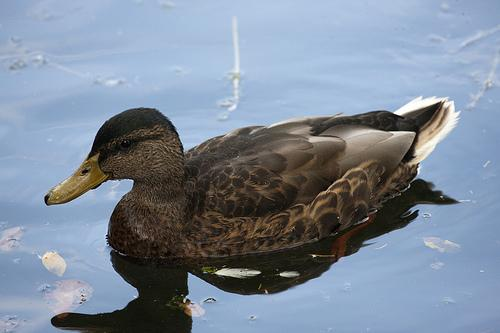Determine the total number of objects detected in the image. There are 39 objects detected in the image. Count and describe the distinctive ripples in the blue water around the duck. There are 9 ripples in the blue water, with varying sizes and shapes. What color is the eye of the duck in the image? The eye of the duck is small and black. What is floating around the duck in the water? There are orange leaves, a branch, and ripples floating around the duck in the water. What is the overall color and mood of the water surrounding the duck? The water is dark blue and calm, with areas of clear light blue, creating a serene mood. Describe the sentiment evoked by the image. The image evokes a sense of calmness and serenity, as the duck peacefully swims in the tranquil water. Give a brief caption summarizing the image. A brown duck swimming in calm and clear blue water with floating leaves and ripples. In your own words, describe the appearance of the duck in the image. The brown duck has a white feathered tail, black and gray feathered body, with bron feathers containing black dots. What is the unique feature on the duck's head and peak? The unique feature is a black line on the duck's head and a little black dot on its peak. Identify any two object interactions taking place in the image. The duck's beak is touching the water, and the tail feathers are interacting with the surrounding water, creating ripples. What is the color of the duck's beak? Brown Which part of the duck appears to have black and gray feathers?  Body What kind of feathered body part is observed in the tail of the duck?  White feathered tail What type of leaves are floating in the water?  Orange leaves What type of body part is pst pf ducks wing feathers?  Part of the brown duck's wing feathers Give a summary of the objects in the image.  Brown duck swimming in pond with leaves, branch, ripples, and reflections in the blue water How does the water appear in this image?  Dark blue and calm with ripples Provide a detailed description of the duck's beak in this image. Large brown peak with black dots and a little black dot on front Can you see a red beak on the duck? While there are multiple captions describing the duck's beak (e.g., "beak of a duck", "peck of a duck", "large brown peak of duck"), none of them mention a red color. What is the main animal in this picture? A duck How does the duck appear to be feeling in this image? Calm, content, undisturbed Is there a distinctive color pattern on the duck's feathers? Bron feathers with black dots Find words to describe the animal in this image.  Brown duck, swimming, pond, head, neck, body, beak, tail, nostril, eye Identify the facial feature that is small and black on the duck.  Small black right eye Do you see a pink feather on the duck's body? Feathers are described in multiple captions (e.g., "feather of a duck", "white feathered tail of duck"), but none of them mention a pink color. What can you tell about the duck's position? Swimming in a pond with ripples in the blue water From options A) tail, B) head, C) foot, D) nostril, identify the part that has a reflection? B) head What aquatic elements can be seen in the picture apart from the duck?   Floating leaves, branch, ripples, and reflections in the blue water Are there any fish swimming near the duck? While there are mentions of objects floating in the water (e.g. "leaves floating in the water" and "branch floating in the water"), there is no mention of fish in the image. Explain the overall setting and situation in this picture. A brown duck is swimming in a pond with leaves, ripples, and reflections in the blue water. Name the floating objects in this image. Leaves, branch, duck Does the duck have an extra pair of wings? There is only one mention of "wing of a duck", which implies the presence of one pair of wings, not an additional one. Is there a group of ducks in the pond? Captions like "a duck in the pond" and "duck swimming in water" suggest that there is only one duck in the image, not a group of ducks. Describe the scene created by this image. A peaceful scene of a brown duck swimming in a pond with floating leaves and calm, rippling water Is the duck's eye green in color? The existing captions only mention a "small black right eye of duck" and "eye of brown duck", but there is no mention of a green eye. What are the prominent colors in this image? Brown, black, gray, white, orange, blue 